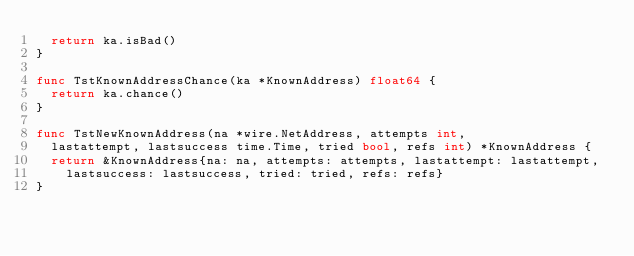<code> <loc_0><loc_0><loc_500><loc_500><_Go_>	return ka.isBad()
}

func TstKnownAddressChance(ka *KnownAddress) float64 {
	return ka.chance()
}

func TstNewKnownAddress(na *wire.NetAddress, attempts int,
	lastattempt, lastsuccess time.Time, tried bool, refs int) *KnownAddress {
	return &KnownAddress{na: na, attempts: attempts, lastattempt: lastattempt,
		lastsuccess: lastsuccess, tried: tried, refs: refs}
}
</code> 